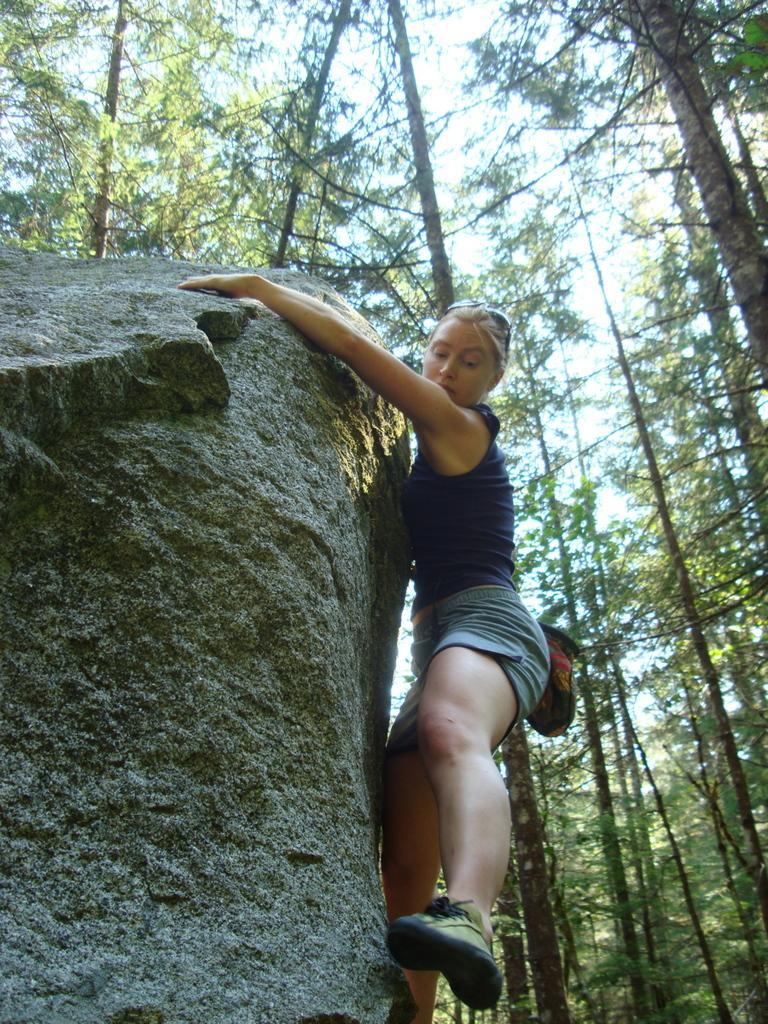Could you give a brief overview of what you see in this image? In this image we can see a woman holding a rock. On the backside we can see a group of trees and the sky. 